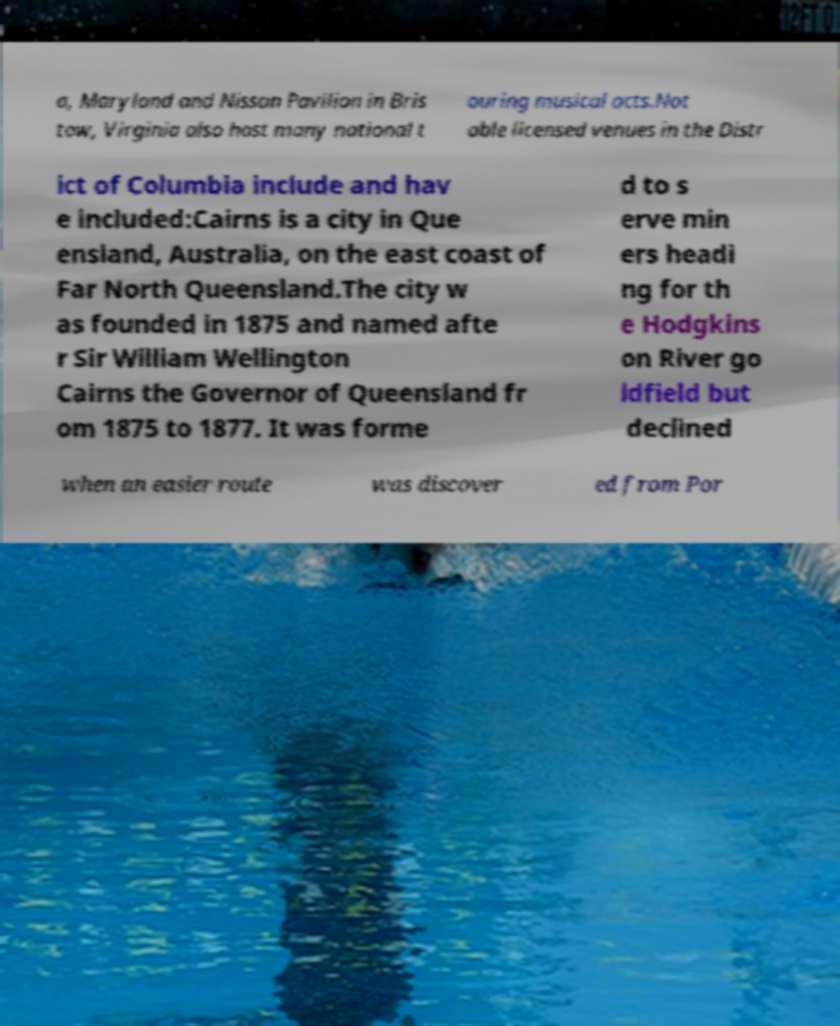Please read and relay the text visible in this image. What does it say? a, Maryland and Nissan Pavilion in Bris tow, Virginia also host many national t ouring musical acts.Not able licensed venues in the Distr ict of Columbia include and hav e included:Cairns is a city in Que ensland, Australia, on the east coast of Far North Queensland.The city w as founded in 1875 and named afte r Sir William Wellington Cairns the Governor of Queensland fr om 1875 to 1877. It was forme d to s erve min ers headi ng for th e Hodgkins on River go ldfield but declined when an easier route was discover ed from Por 